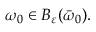Convert formula to latex. <formula><loc_0><loc_0><loc_500><loc_500>\omega _ { 0 } \in B _ { \varepsilon } ( \bar { \omega } _ { 0 } ) .</formula> 